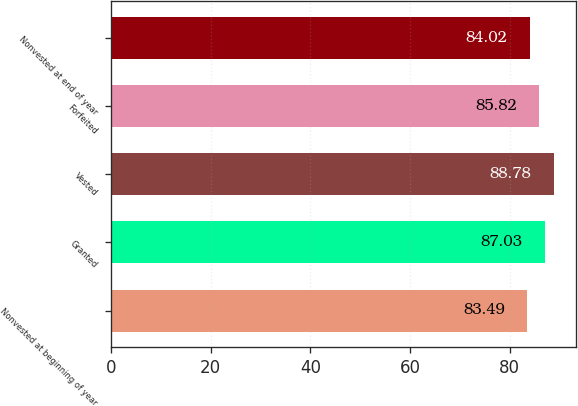Convert chart. <chart><loc_0><loc_0><loc_500><loc_500><bar_chart><fcel>Nonvested at beginning of year<fcel>Granted<fcel>Vested<fcel>Forfeited<fcel>Nonvested at end of year<nl><fcel>83.49<fcel>87.03<fcel>88.78<fcel>85.82<fcel>84.02<nl></chart> 